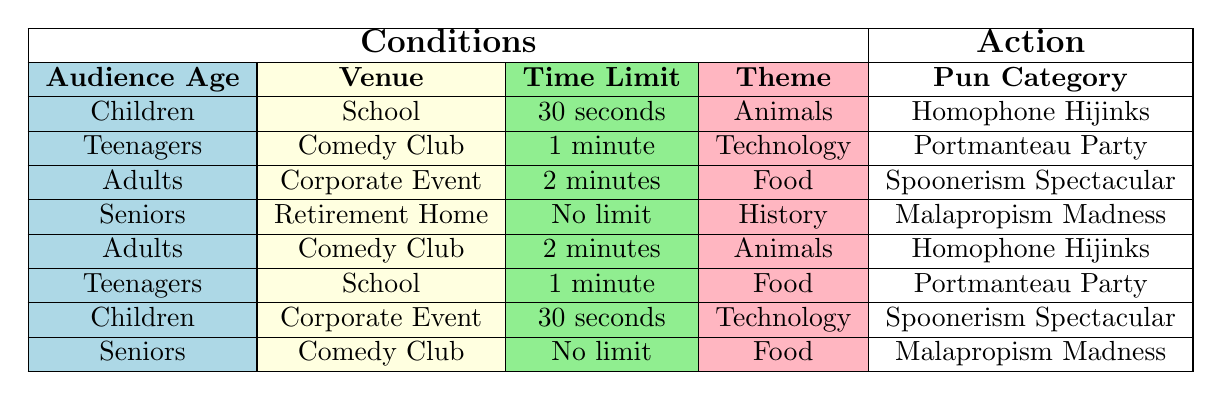What pun category is recommended for Children's jokes at a School with a 30-second limit and an Animal theme? According to the table, when the conditions are "Children," "School," "30 seconds," and "Animals," the recommended pun category is "Homophone Hijinks."
Answer: Homophone Hijinks Is "Portmanteau Party" suitable for adults performing at a Corporate Event for 2 minutes with the Food theme? Looking at the table, the conditions for "Portmanteau Party" include "Teenagers," "Comedy Club," and "1 minute," not Adult conditions in this venue and time frame. Thus, it's not suitable for adults.
Answer: No Which pun category do Seniors perform at a Comedy Club with no time limit and a Food theme? In the table, the row matching "Seniors," "Comedy Club," "No limit," and "Food" shows that the pun category is "Malapropism Madness."
Answer: Malapropism Madness How many pun categories are associated with the theme of Animals? There are two rows with "Animals": one for "Children" at "School" and one for "Adults" at "Comedy Club." Therefore, there are two unique pun categories: "Homophone Hijinks" and "Homophone Hijinks."
Answer: 1 Is there a pun category for "Teenagers" and "Corporate Event" with "Technology" and a "30 seconds" limit? The table does not list a combination fulfilling these conditions. The closest is "Children," "Corporate Event," "Technology," which suggests that Teenagers wouldn't fit this pun category.
Answer: No If a group of Adults is performing at a Comedy Club for 2 minutes with an Animal theme, what is the recommended pun category? In the table, the entry for "Adults," "Comedy Club," "2 minutes," and "Animals" shows "Homophone Hijinks" as the appropriate pun category.
Answer: Homophone Hijinks What is the pun category for Teenagers at a School with a 1-minute limit focused on Food? The table indicates that when considering "Teenagers," "School," "1 minute," and "Food," the option is "Portmanteau Party."
Answer: Portmanteau Party Are there any pun categories that are suitable for Children with a Technology theme? There is one matching row: "Children," "Corporate Event," "30 seconds," and "Technology," which fits, indicating there is a pun category for this setup.
Answer: Yes 